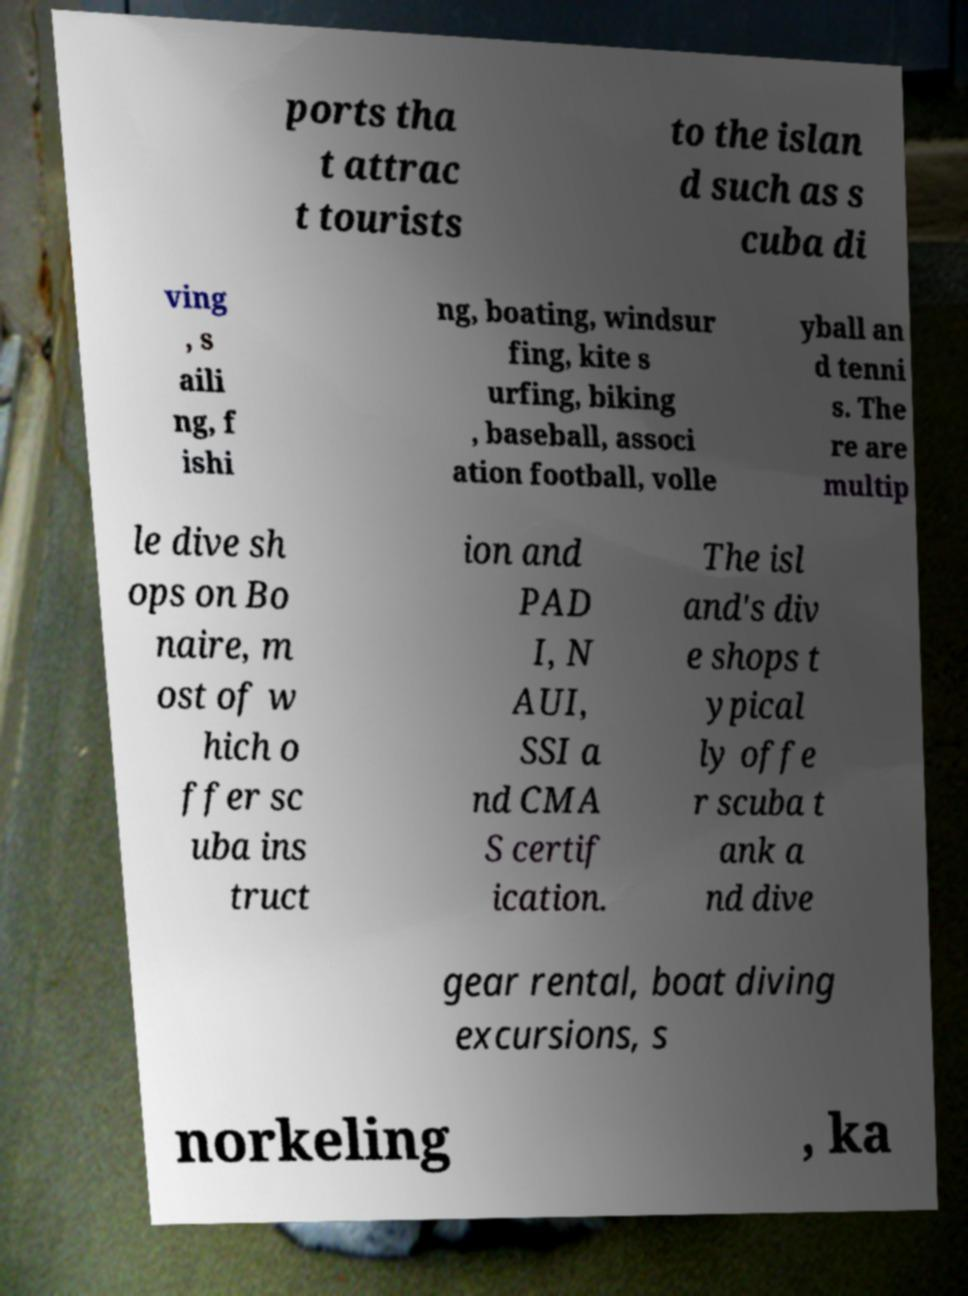Can you accurately transcribe the text from the provided image for me? ports tha t attrac t tourists to the islan d such as s cuba di ving , s aili ng, f ishi ng, boating, windsur fing, kite s urfing, biking , baseball, associ ation football, volle yball an d tenni s. The re are multip le dive sh ops on Bo naire, m ost of w hich o ffer sc uba ins truct ion and PAD I, N AUI, SSI a nd CMA S certif ication. The isl and's div e shops t ypical ly offe r scuba t ank a nd dive gear rental, boat diving excursions, s norkeling , ka 